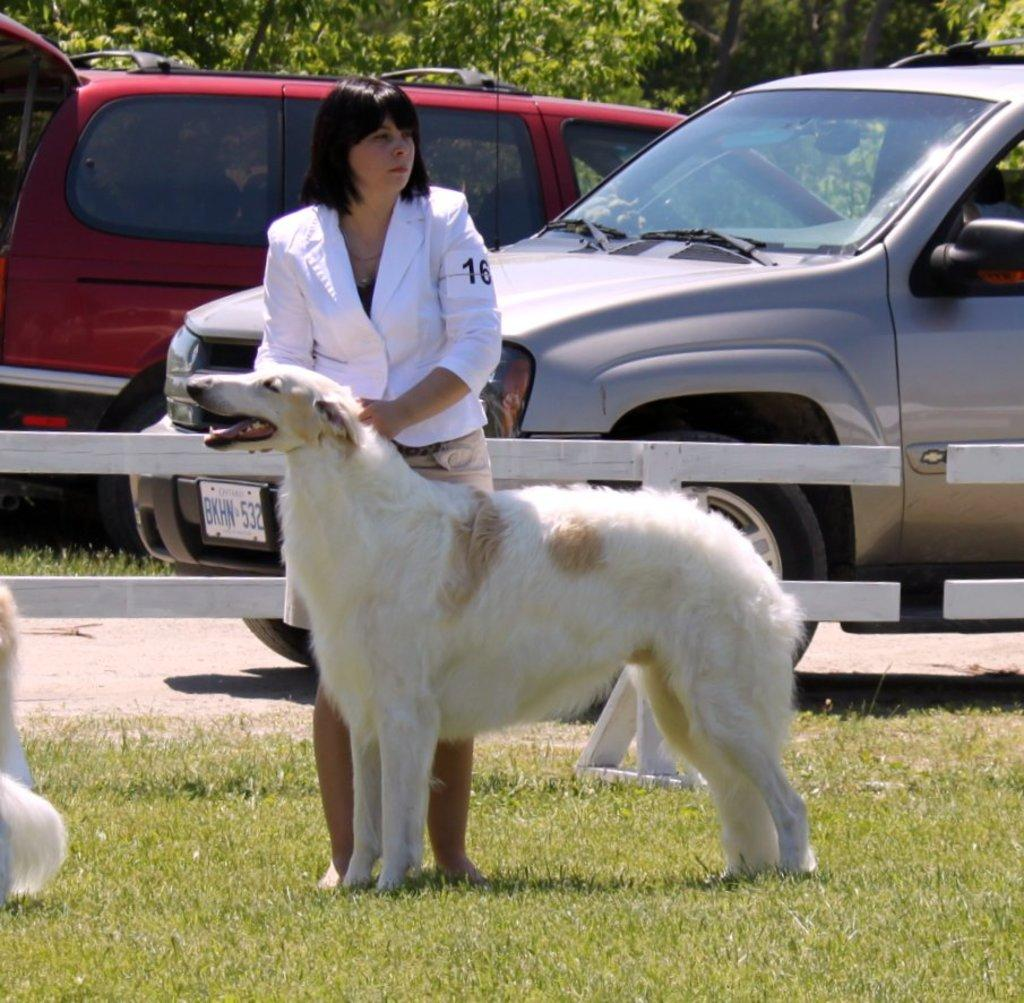Who is present in the image? There is a woman in the image. What is the woman holding? The woman is holding a dog. Where is the dog positioned in relation to the woman? The dog is in front of the woman. What type of terrain is visible at the bottom of the image? There is grass at the bottom of the image. What can be seen in the background of the image? There are two cars and trees in the background of the image. What type of fencing is present in the background of the image? There is wooden fencing in the background of the image. What type of coal is being used by the laborer in the image? There is no laborer or coal present in the image. The image features a woman holding a dog, grass at the bottom, and a background with cars, trees, and wooden fencing. 